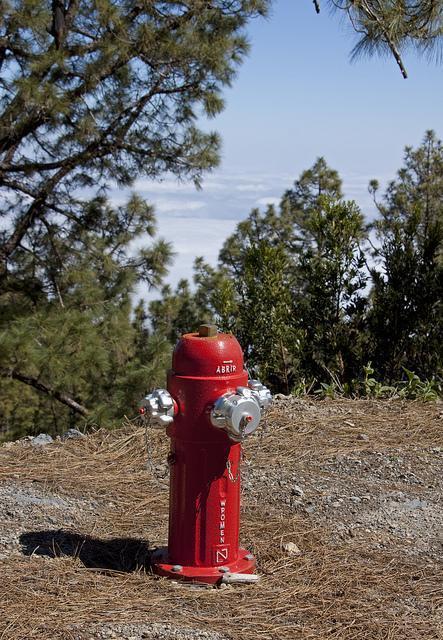How many silver cars are in the image?
Give a very brief answer. 0. 